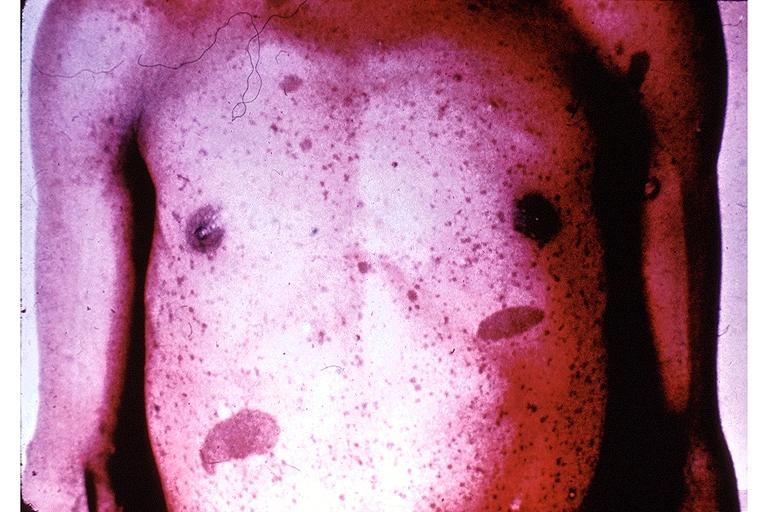what does this image show?
Answer the question using a single word or phrase. Neurofibromatosis-cafe-au-lait pigmentation 